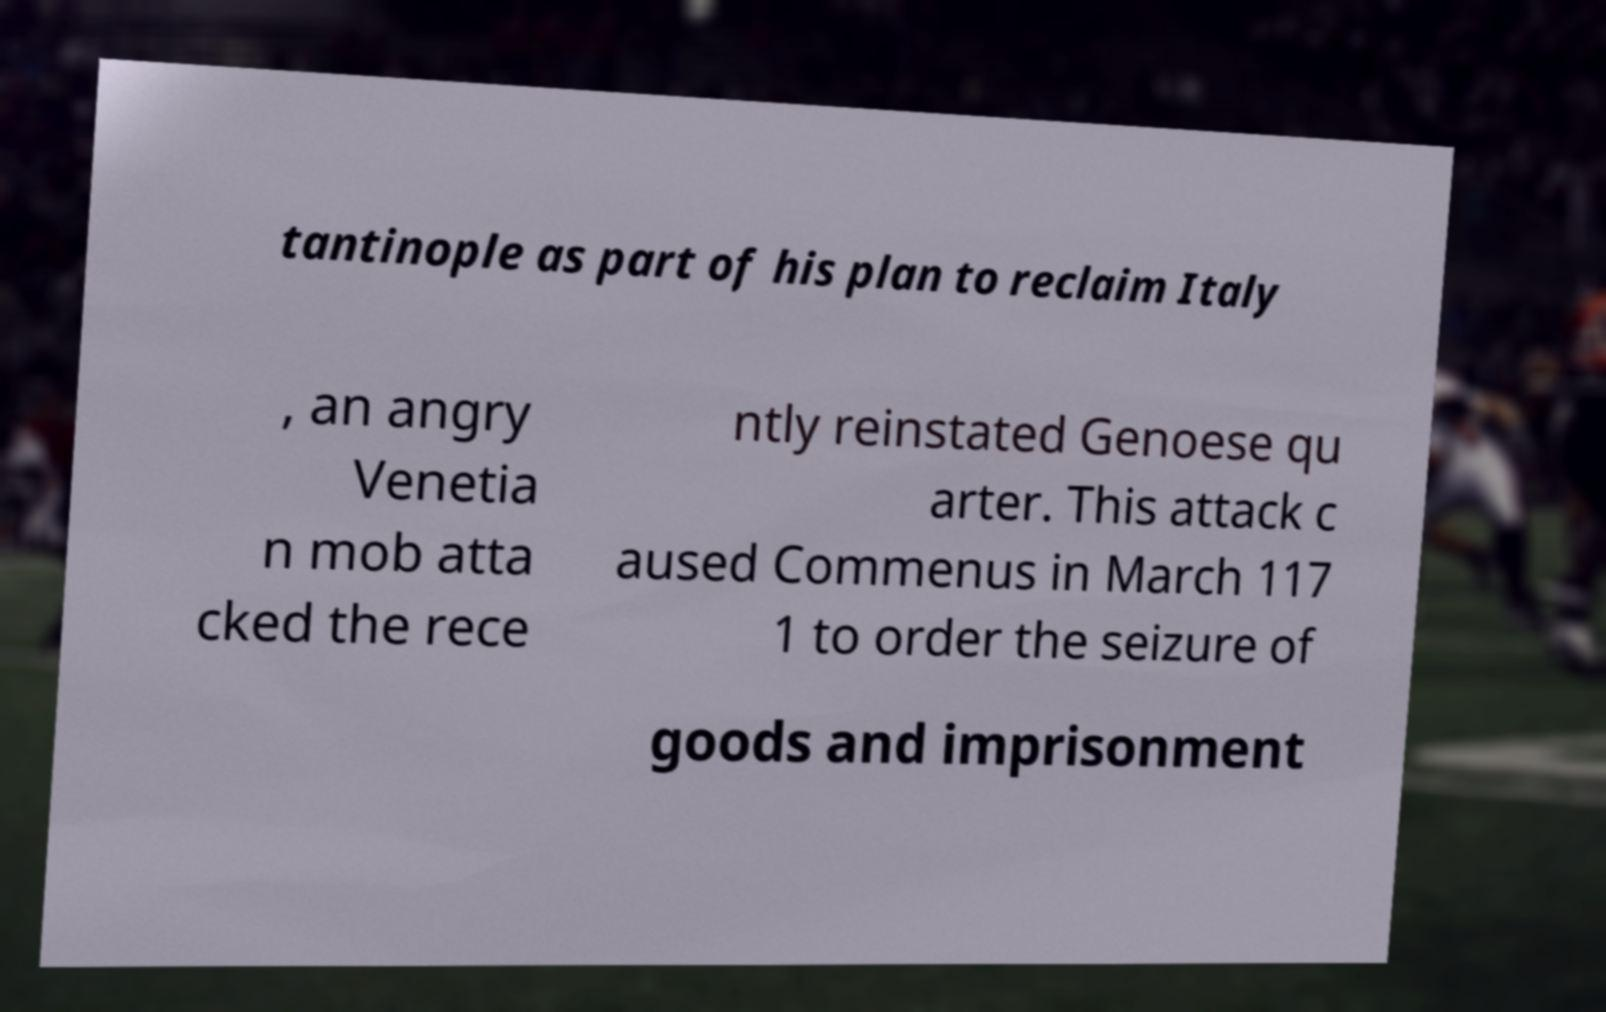Please read and relay the text visible in this image. What does it say? tantinople as part of his plan to reclaim Italy , an angry Venetia n mob atta cked the rece ntly reinstated Genoese qu arter. This attack c aused Commenus in March 117 1 to order the seizure of goods and imprisonment 